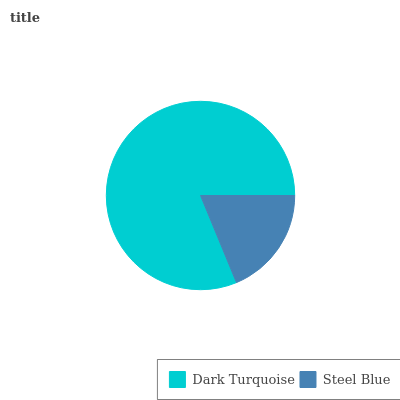Is Steel Blue the minimum?
Answer yes or no. Yes. Is Dark Turquoise the maximum?
Answer yes or no. Yes. Is Steel Blue the maximum?
Answer yes or no. No. Is Dark Turquoise greater than Steel Blue?
Answer yes or no. Yes. Is Steel Blue less than Dark Turquoise?
Answer yes or no. Yes. Is Steel Blue greater than Dark Turquoise?
Answer yes or no. No. Is Dark Turquoise less than Steel Blue?
Answer yes or no. No. Is Dark Turquoise the high median?
Answer yes or no. Yes. Is Steel Blue the low median?
Answer yes or no. Yes. Is Steel Blue the high median?
Answer yes or no. No. Is Dark Turquoise the low median?
Answer yes or no. No. 